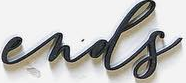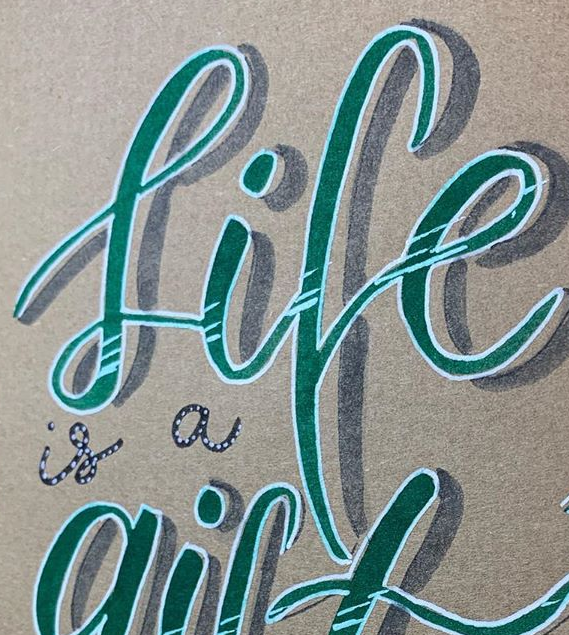Identify the words shown in these images in order, separated by a semicolon. ends; life 